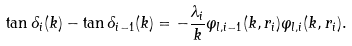<formula> <loc_0><loc_0><loc_500><loc_500>\tan { \delta _ { i } ( k ) } - \tan { \delta _ { i - 1 } ( k ) } = - \frac { \lambda _ { i } } { k } \varphi _ { l , i - 1 } ( k , r _ { i } ) \varphi _ { l , i } ( k , r _ { i } ) .</formula> 